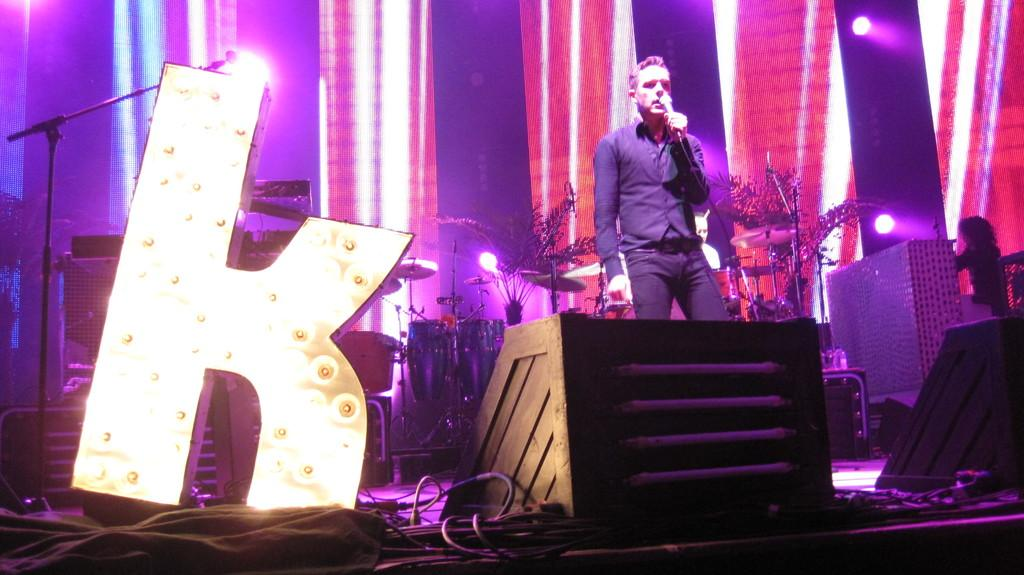What is the person in the image holding? The person in the image is holding a mic. What else can be seen in the image related to music? Musical instruments are present in the image. What can be seen in the image that might be used for connecting equipment? There are wires in the image. What is attached to the wall in the image? Lights are attached to the wall in the image. What type of plants are visible in the image? Potted plants are visible in the image. What is on the table in the image? There is a table with bottles in the image. What other objects are on the stage in the image? There are additional objects on the stage in the image. What country is being observed in the image? There is no country being observed in the image; it is a stage with various objects and a person holding a mic. What object is being smashed in the image? There is no object being smashed in the image. 